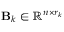Convert formula to latex. <formula><loc_0><loc_0><loc_500><loc_500>B _ { k } \in \mathbb { R } ^ { n \times r _ { k } }</formula> 